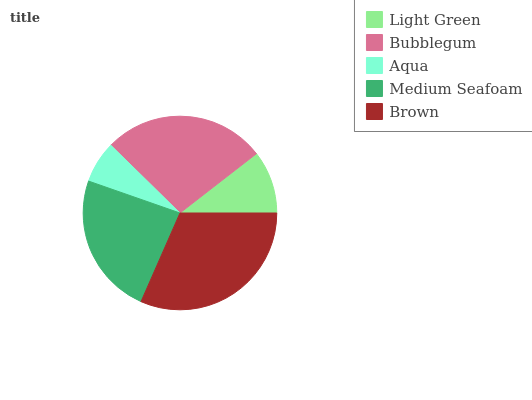Is Aqua the minimum?
Answer yes or no. Yes. Is Brown the maximum?
Answer yes or no. Yes. Is Bubblegum the minimum?
Answer yes or no. No. Is Bubblegum the maximum?
Answer yes or no. No. Is Bubblegum greater than Light Green?
Answer yes or no. Yes. Is Light Green less than Bubblegum?
Answer yes or no. Yes. Is Light Green greater than Bubblegum?
Answer yes or no. No. Is Bubblegum less than Light Green?
Answer yes or no. No. Is Medium Seafoam the high median?
Answer yes or no. Yes. Is Medium Seafoam the low median?
Answer yes or no. Yes. Is Aqua the high median?
Answer yes or no. No. Is Light Green the low median?
Answer yes or no. No. 